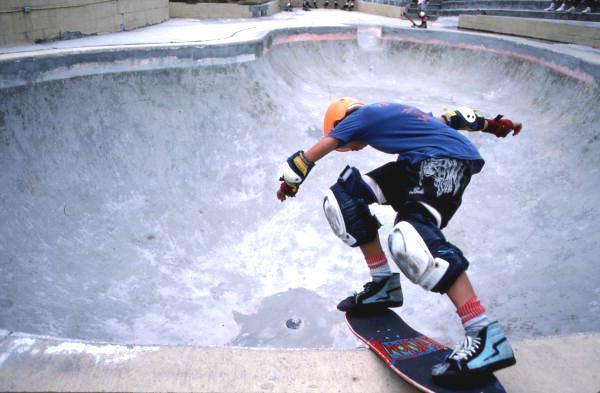How many bananas do you see?
Give a very brief answer. 0. 